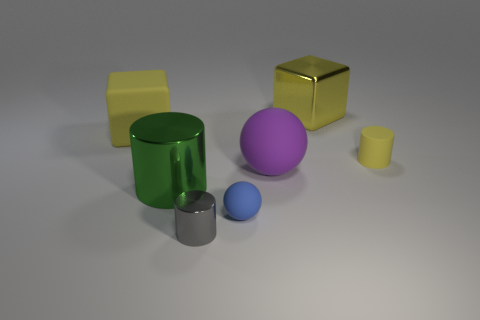Add 2 yellow metal objects. How many objects exist? 9 Subtract all spheres. How many objects are left? 5 Add 6 big red cylinders. How many big red cylinders exist? 6 Subtract 0 gray blocks. How many objects are left? 7 Subtract all cyan rubber objects. Subtract all yellow objects. How many objects are left? 4 Add 4 large metal things. How many large metal things are left? 6 